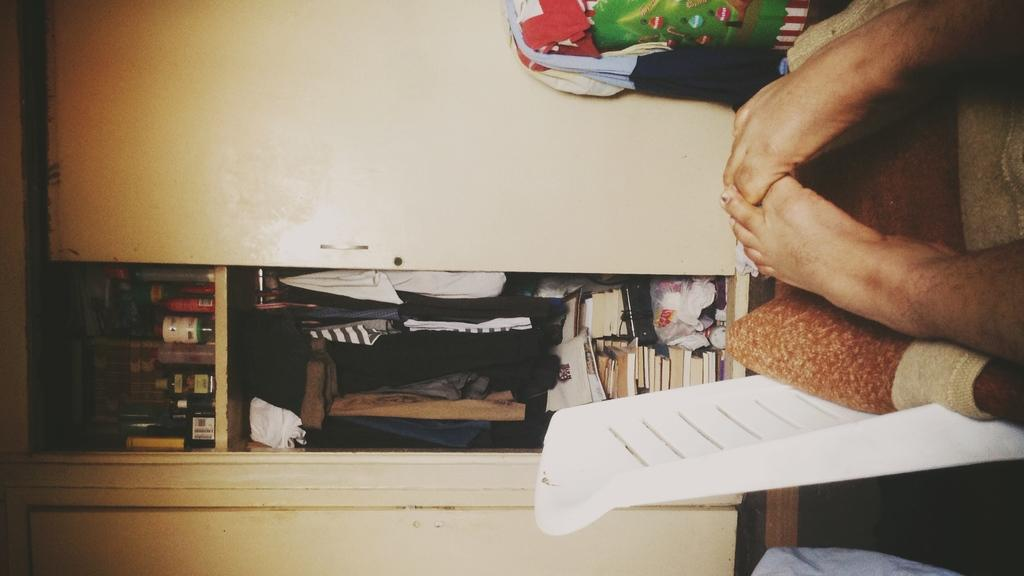What body part is visible in the image? There are a person's legs visible in the image. What piece of furniture is in the image? There is a chair in the image. What items are related to clothing in the image? There are clothes in the image, and inside the cupboard, there are clothes as well. What type of storage furniture is in the image? There is a cupboard in the image. What other items can be found inside the cupboard? Inside the cupboard, there are boxes, bottles, and other objects. What is the grandfather thinking about while sitting on the chair in the image? There is no information about a grandfather or any thoughts in the image. The image only shows a person's legs, a chair, clothes, and a cupboard with various items inside. 